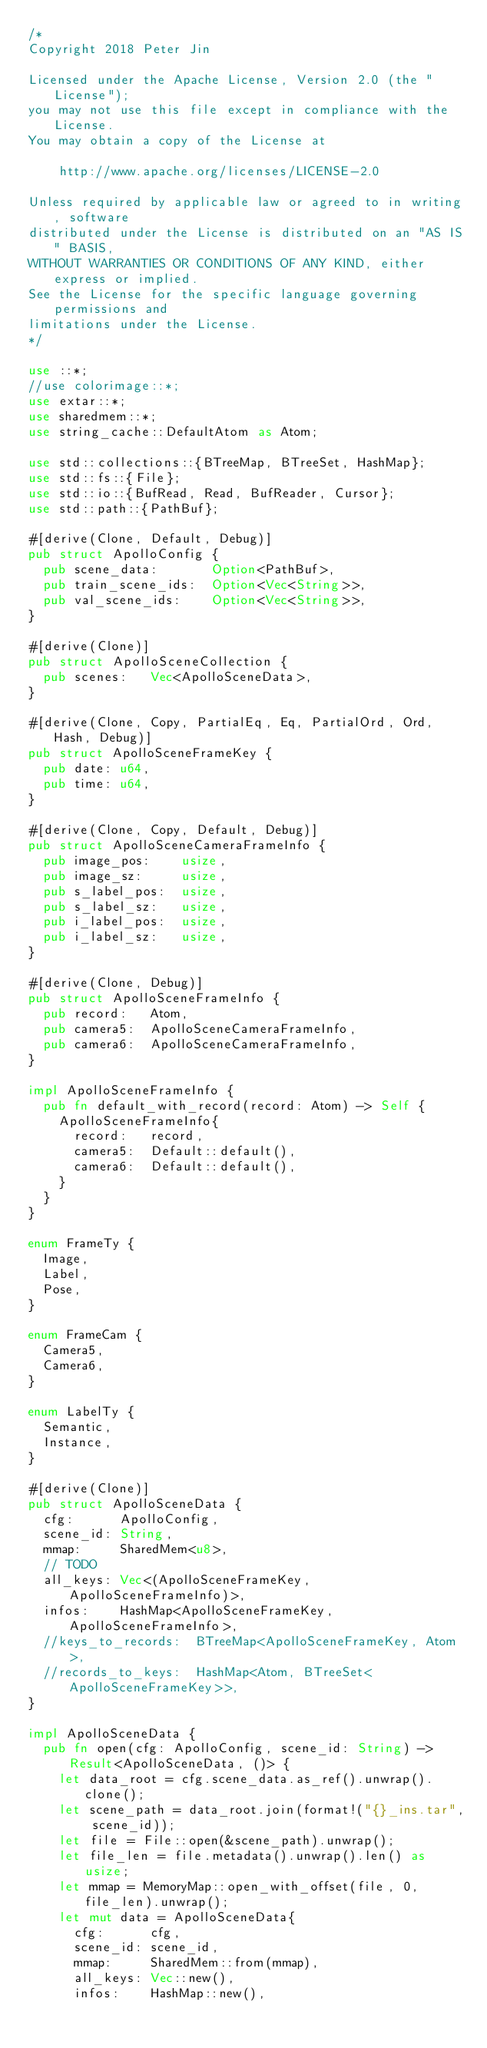Convert code to text. <code><loc_0><loc_0><loc_500><loc_500><_Rust_>/*
Copyright 2018 Peter Jin

Licensed under the Apache License, Version 2.0 (the "License");
you may not use this file except in compliance with the License.
You may obtain a copy of the License at

    http://www.apache.org/licenses/LICENSE-2.0

Unless required by applicable law or agreed to in writing, software
distributed under the License is distributed on an "AS IS" BASIS,
WITHOUT WARRANTIES OR CONDITIONS OF ANY KIND, either express or implied.
See the License for the specific language governing permissions and
limitations under the License.
*/

use ::*;
//use colorimage::*;
use extar::*;
use sharedmem::*;
use string_cache::DefaultAtom as Atom;

use std::collections::{BTreeMap, BTreeSet, HashMap};
use std::fs::{File};
use std::io::{BufRead, Read, BufReader, Cursor};
use std::path::{PathBuf};

#[derive(Clone, Default, Debug)]
pub struct ApolloConfig {
  pub scene_data:       Option<PathBuf>,
  pub train_scene_ids:  Option<Vec<String>>,
  pub val_scene_ids:    Option<Vec<String>>,
}

#[derive(Clone)]
pub struct ApolloSceneCollection {
  pub scenes:   Vec<ApolloSceneData>,
}

#[derive(Clone, Copy, PartialEq, Eq, PartialOrd, Ord, Hash, Debug)]
pub struct ApolloSceneFrameKey {
  pub date: u64,
  pub time: u64,
}

#[derive(Clone, Copy, Default, Debug)]
pub struct ApolloSceneCameraFrameInfo {
  pub image_pos:    usize,
  pub image_sz:     usize,
  pub s_label_pos:  usize,
  pub s_label_sz:   usize,
  pub i_label_pos:  usize,
  pub i_label_sz:   usize,
}

#[derive(Clone, Debug)]
pub struct ApolloSceneFrameInfo {
  pub record:   Atom,
  pub camera5:  ApolloSceneCameraFrameInfo,
  pub camera6:  ApolloSceneCameraFrameInfo,
}

impl ApolloSceneFrameInfo {
  pub fn default_with_record(record: Atom) -> Self {
    ApolloSceneFrameInfo{
      record:   record,
      camera5:  Default::default(),
      camera6:  Default::default(),
    }
  }
}

enum FrameTy {
  Image,
  Label,
  Pose,
}

enum FrameCam {
  Camera5,
  Camera6,
}

enum LabelTy {
  Semantic,
  Instance,
}

#[derive(Clone)]
pub struct ApolloSceneData {
  cfg:      ApolloConfig,
  scene_id: String,
  mmap:     SharedMem<u8>,
  // TODO
  all_keys: Vec<(ApolloSceneFrameKey, ApolloSceneFrameInfo)>,
  infos:    HashMap<ApolloSceneFrameKey, ApolloSceneFrameInfo>,
  //keys_to_records:  BTreeMap<ApolloSceneFrameKey, Atom>,
  //records_to_keys:  HashMap<Atom, BTreeSet<ApolloSceneFrameKey>>,
}

impl ApolloSceneData {
  pub fn open(cfg: ApolloConfig, scene_id: String) -> Result<ApolloSceneData, ()> {
    let data_root = cfg.scene_data.as_ref().unwrap().clone();
    let scene_path = data_root.join(format!("{}_ins.tar", scene_id));
    let file = File::open(&scene_path).unwrap();
    let file_len = file.metadata().unwrap().len() as usize;
    let mmap = MemoryMap::open_with_offset(file, 0, file_len).unwrap();
    let mut data = ApolloSceneData{
      cfg:      cfg,
      scene_id: scene_id,
      mmap:     SharedMem::from(mmap),
      all_keys: Vec::new(),
      infos:    HashMap::new(),</code> 